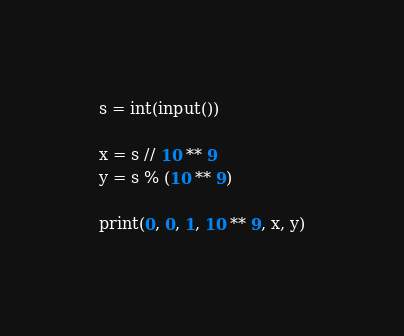Convert code to text. <code><loc_0><loc_0><loc_500><loc_500><_Python_>s = int(input())

x = s // 10 ** 9
y = s % (10 ** 9) 
 
print(0, 0, 1, 10 ** 9, x, y)
</code> 